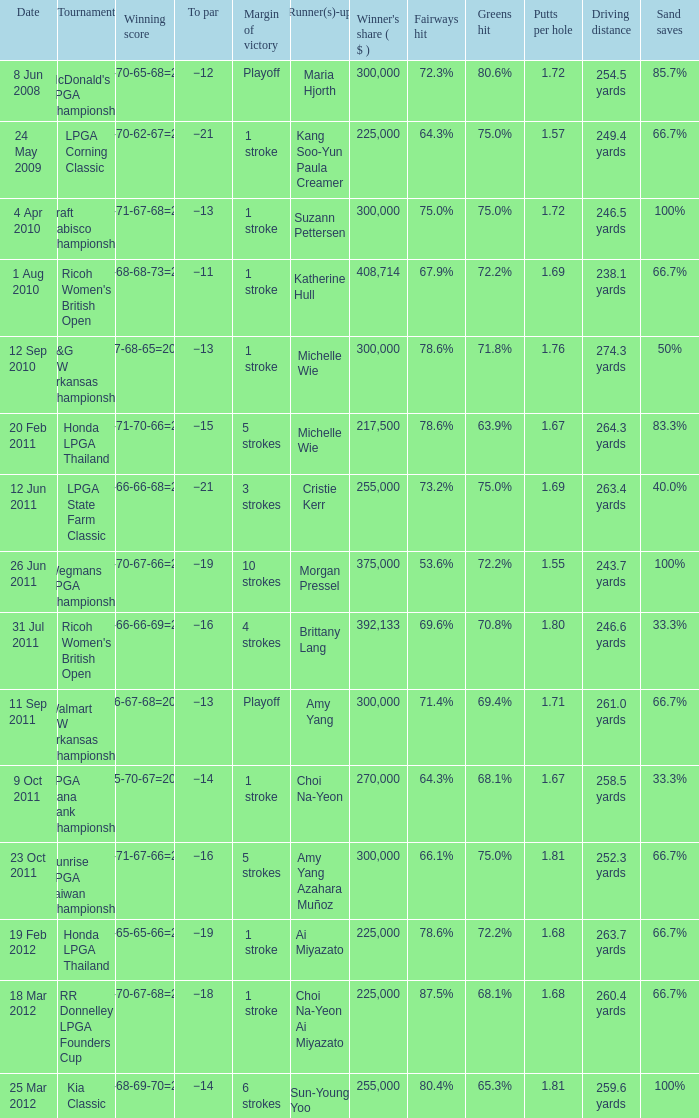Who was the runner-up in the RR Donnelley LPGA Founders Cup? Choi Na-Yeon Ai Miyazato. 